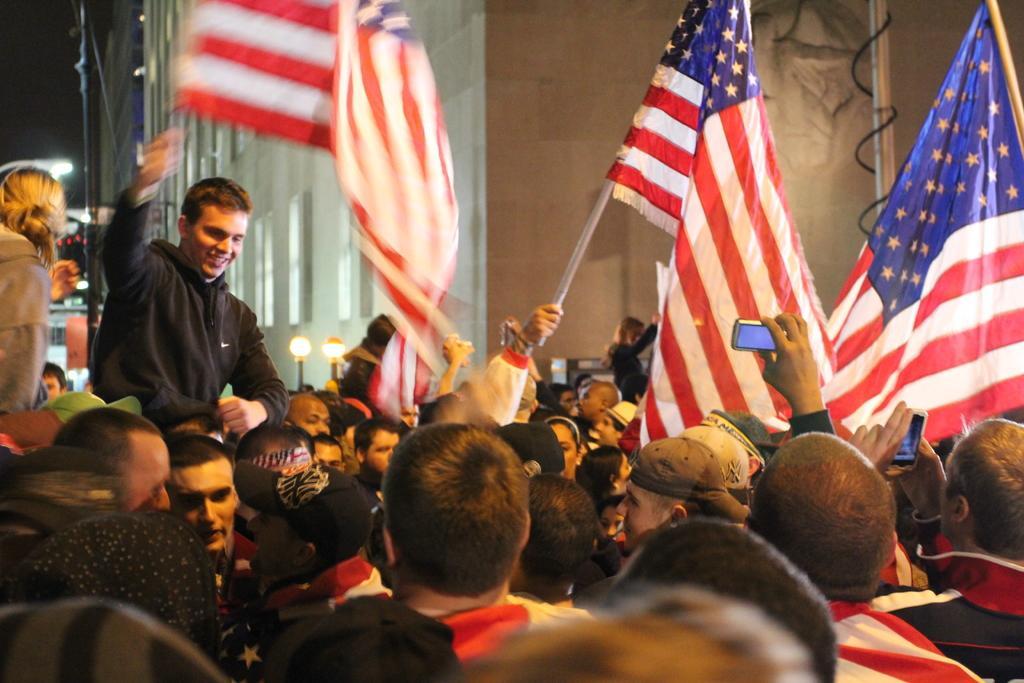Describe this image in one or two sentences. In this image I can see people, lights poles, buildings and objects. Among them two people are holding mobiles and few people are holding flags.   